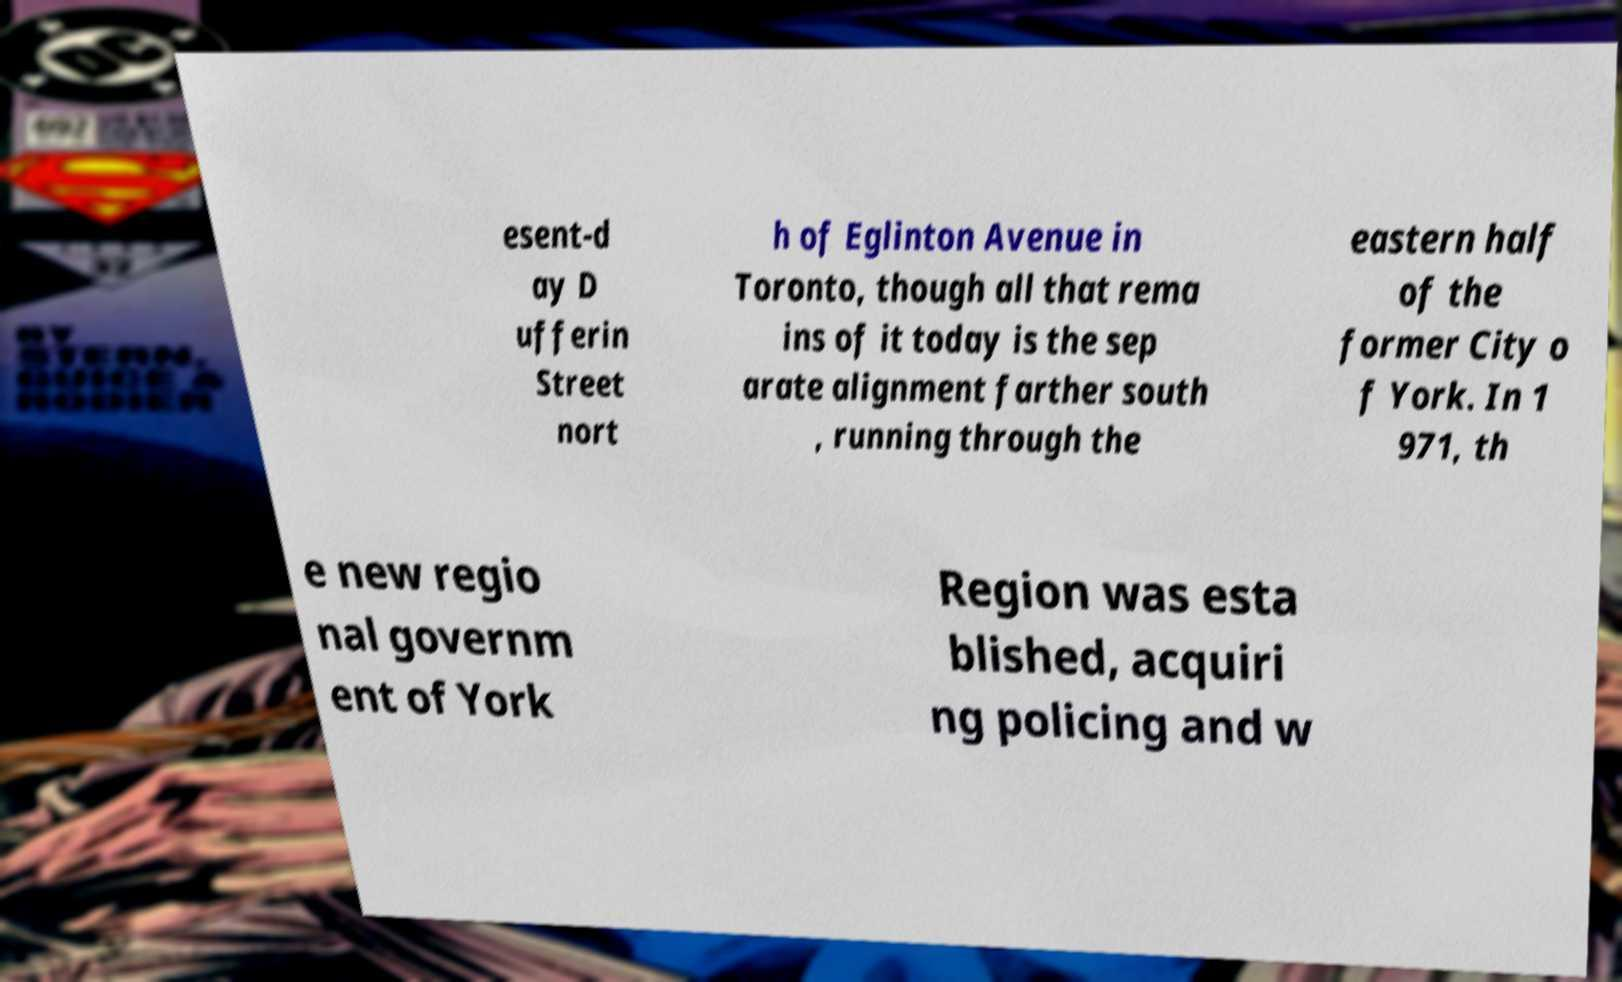Can you accurately transcribe the text from the provided image for me? esent-d ay D ufferin Street nort h of Eglinton Avenue in Toronto, though all that rema ins of it today is the sep arate alignment farther south , running through the eastern half of the former City o f York. In 1 971, th e new regio nal governm ent of York Region was esta blished, acquiri ng policing and w 